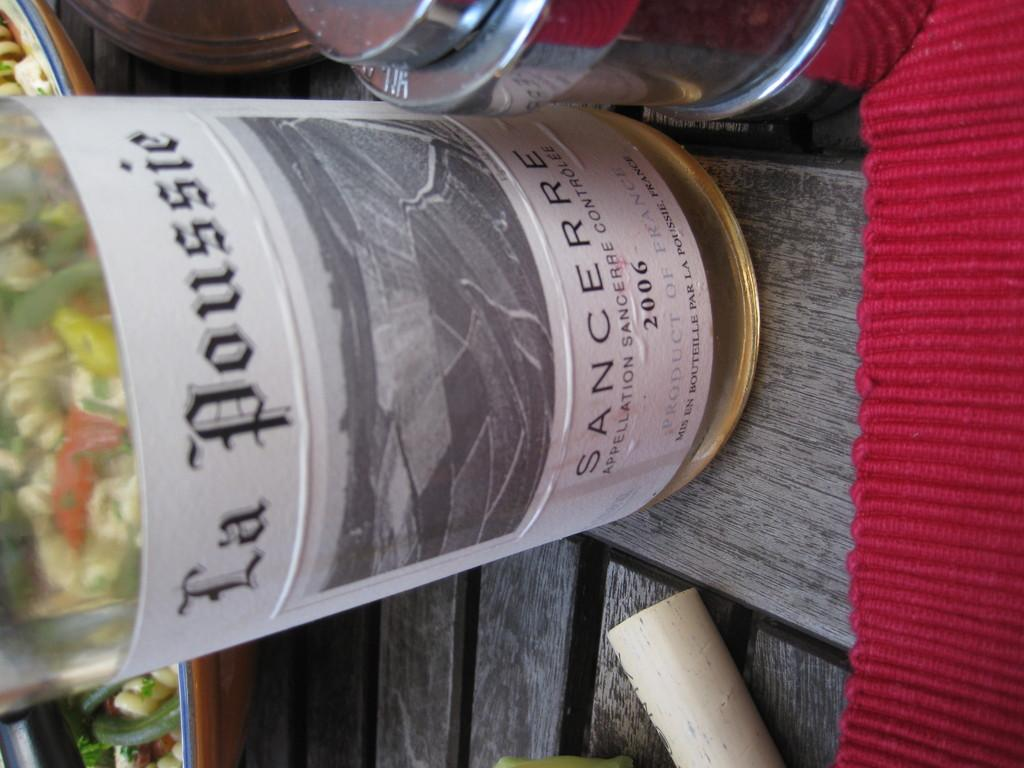<image>
Provide a brief description of the given image. A bottle of Wine that says La Poussie Sancerre is on a wooden table. 